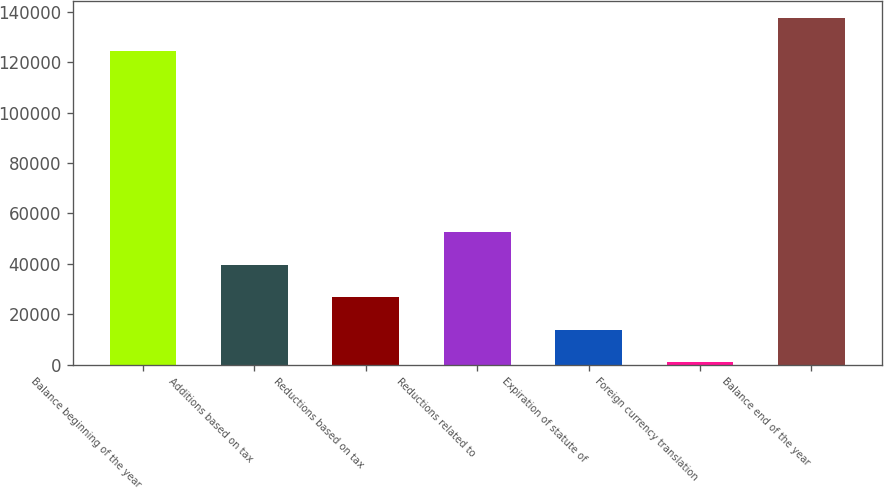Convert chart. <chart><loc_0><loc_0><loc_500><loc_500><bar_chart><fcel>Balance beginning of the year<fcel>Additions based on tax<fcel>Reductions based on tax<fcel>Reductions related to<fcel>Expiration of statute of<fcel>Foreign currency translation<fcel>Balance end of the year<nl><fcel>124605<fcel>39576.9<fcel>26692.6<fcel>52461.2<fcel>13808.3<fcel>924<fcel>137489<nl></chart> 